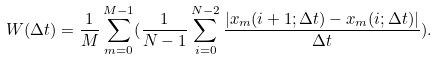<formula> <loc_0><loc_0><loc_500><loc_500>W ( \Delta t ) = \frac { 1 } { M } \sum _ { m = 0 } ^ { M - 1 } ( \frac { 1 } { N - 1 } \sum _ { i = 0 } ^ { N - 2 } \frac { | x _ { m } ( i + 1 ; \Delta t ) - x _ { m } ( i ; \Delta t ) | } { \Delta t } ) .</formula> 